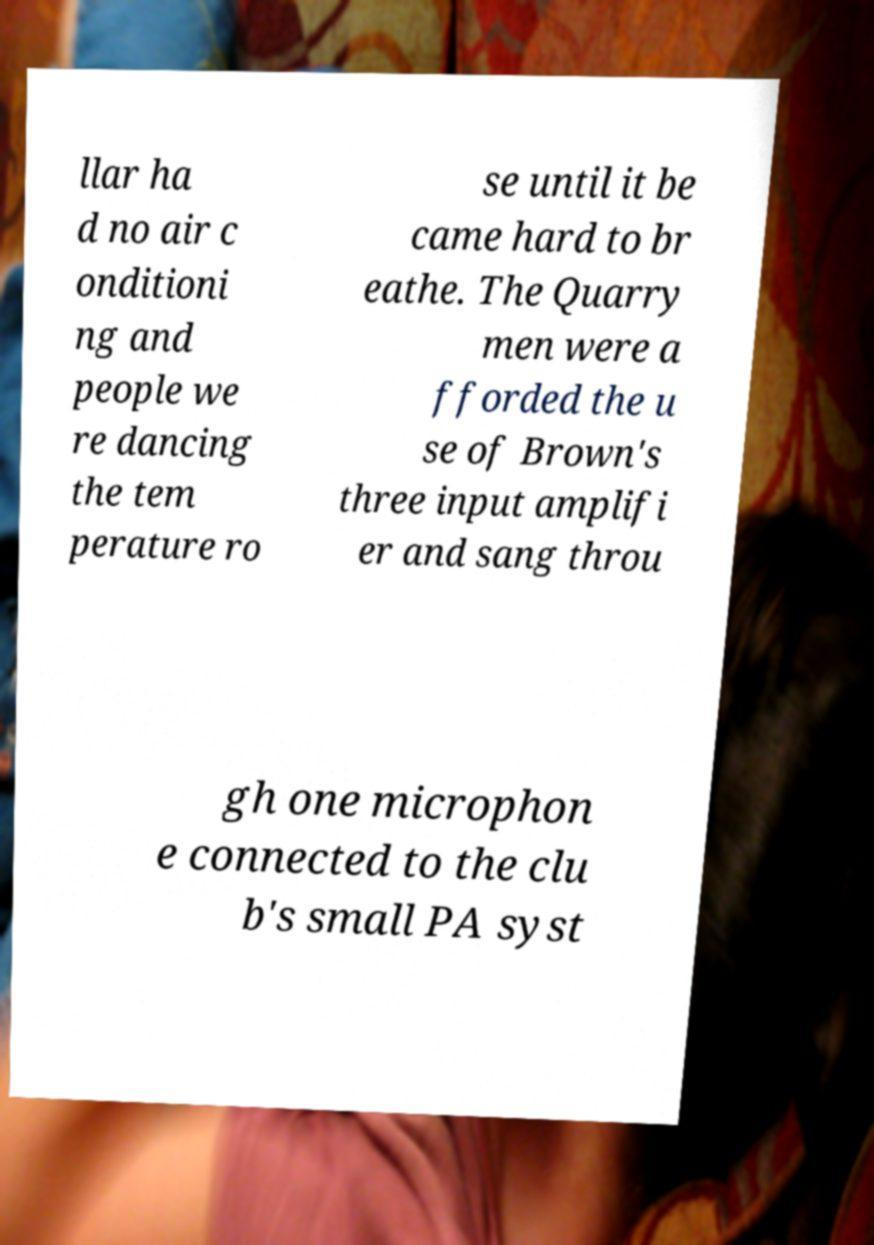Could you extract and type out the text from this image? llar ha d no air c onditioni ng and people we re dancing the tem perature ro se until it be came hard to br eathe. The Quarry men were a fforded the u se of Brown's three input amplifi er and sang throu gh one microphon e connected to the clu b's small PA syst 